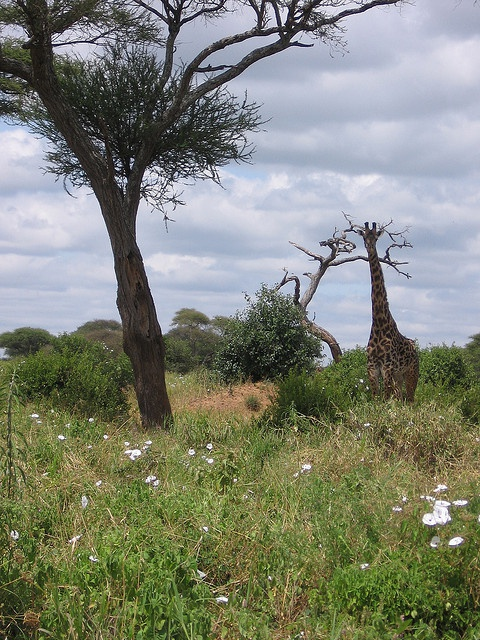Describe the objects in this image and their specific colors. I can see a giraffe in gray and black tones in this image. 